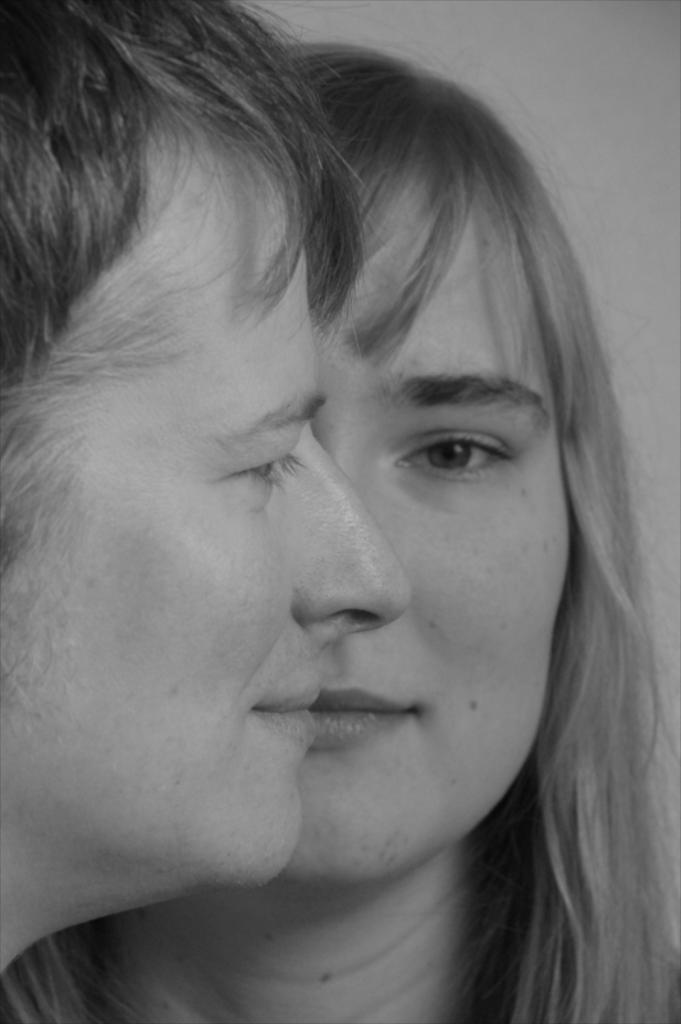What is the color scheme of the image? The image is black and white. Can you describe the people in the image? There is a man and a woman in the image, and both are smiling. What is visible in the background of the image? There is a wall in the background of the image. What type of rhythm can be heard in the image? There is no sound or rhythm present in the image, as it is a still photograph. What kind of apparatus is being used by the man in the image? There is no apparatus visible in the image; the man is simply standing and smiling. 